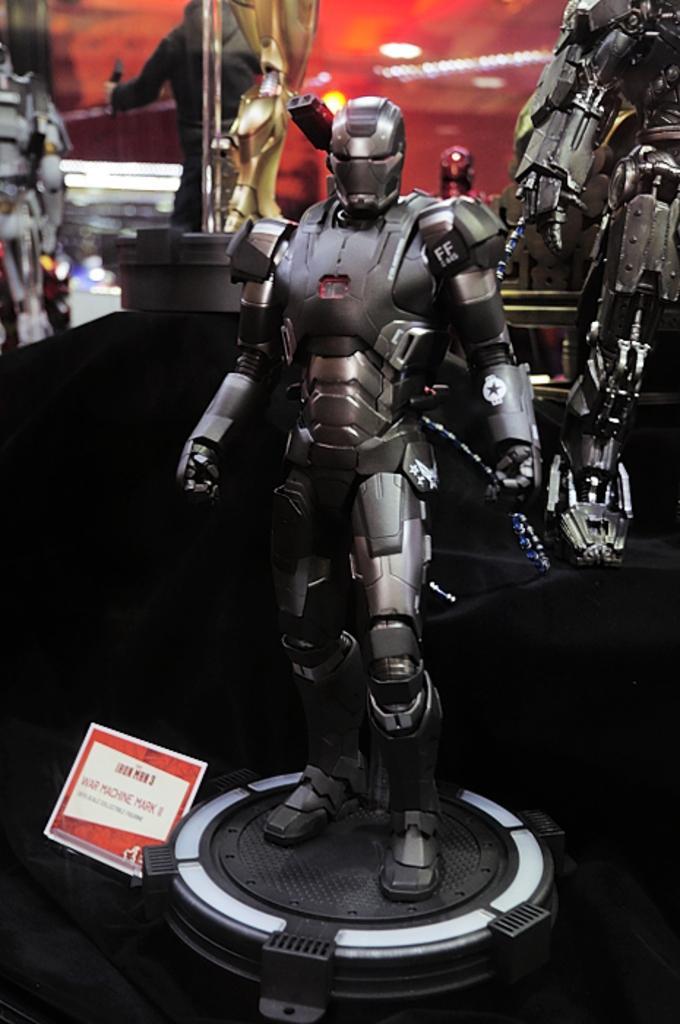Please provide a concise description of this image. In this image I can see a toy which is black and silver in color on the black colored object. I can see the white and red colored board and in the background I can see few other toys. 